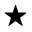<formula> <loc_0><loc_0><loc_500><loc_500>^ { * }</formula> 